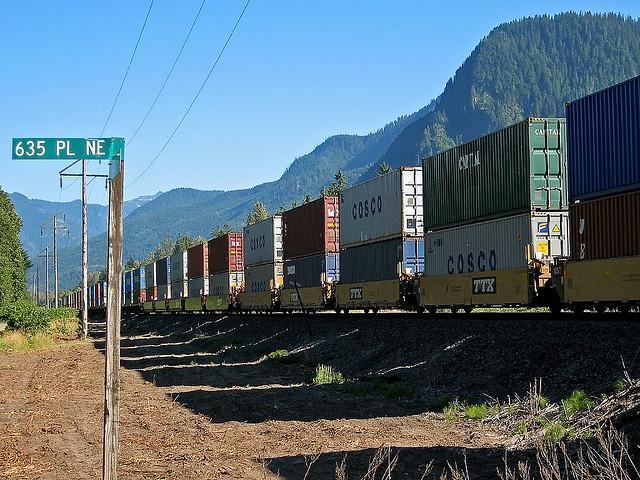How many men are wearing the number eighteen on their jersey?
Give a very brief answer. 0. 